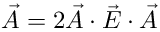<formula> <loc_0><loc_0><loc_500><loc_500>\overset { \vartriangle } { \vec { A } } = 2 \vec { A } \cdot \vec { E } \cdot \vec { A }</formula> 